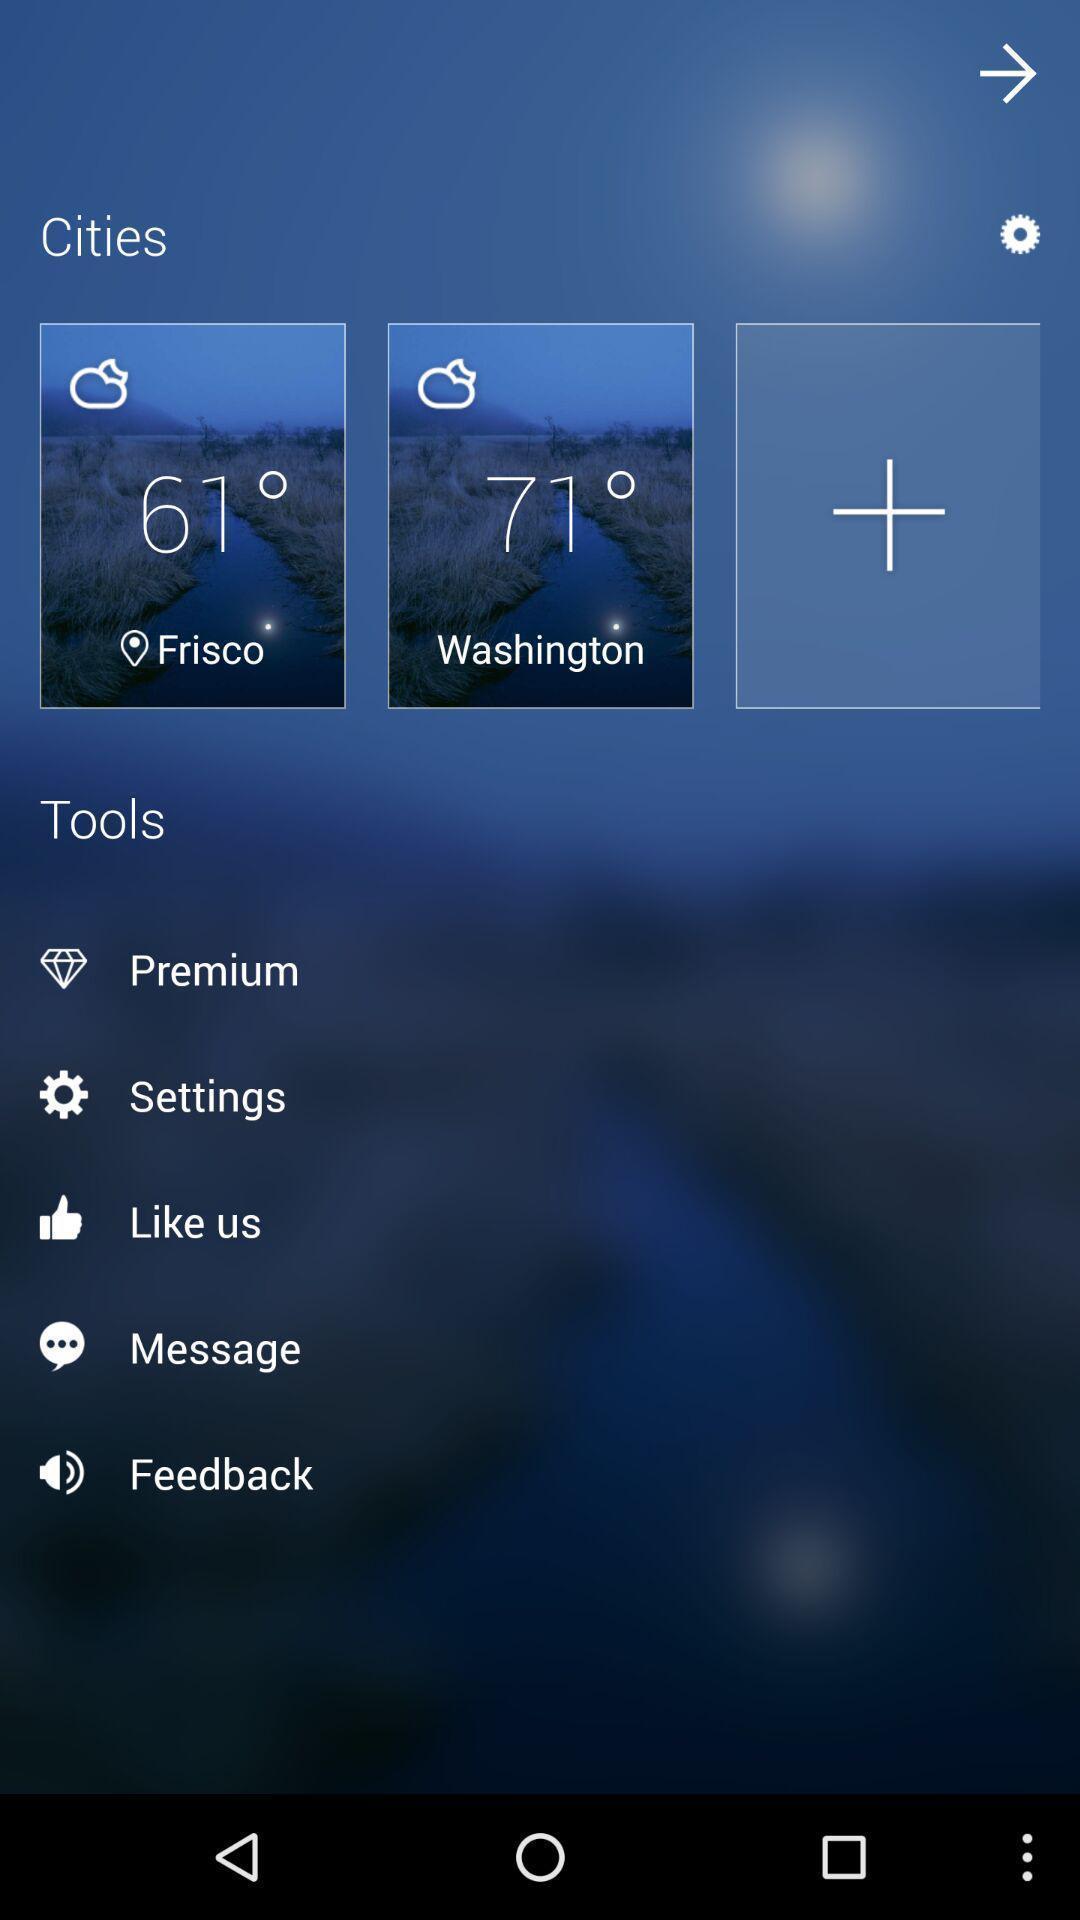What details can you identify in this image? Screen showing list of various tool options. 